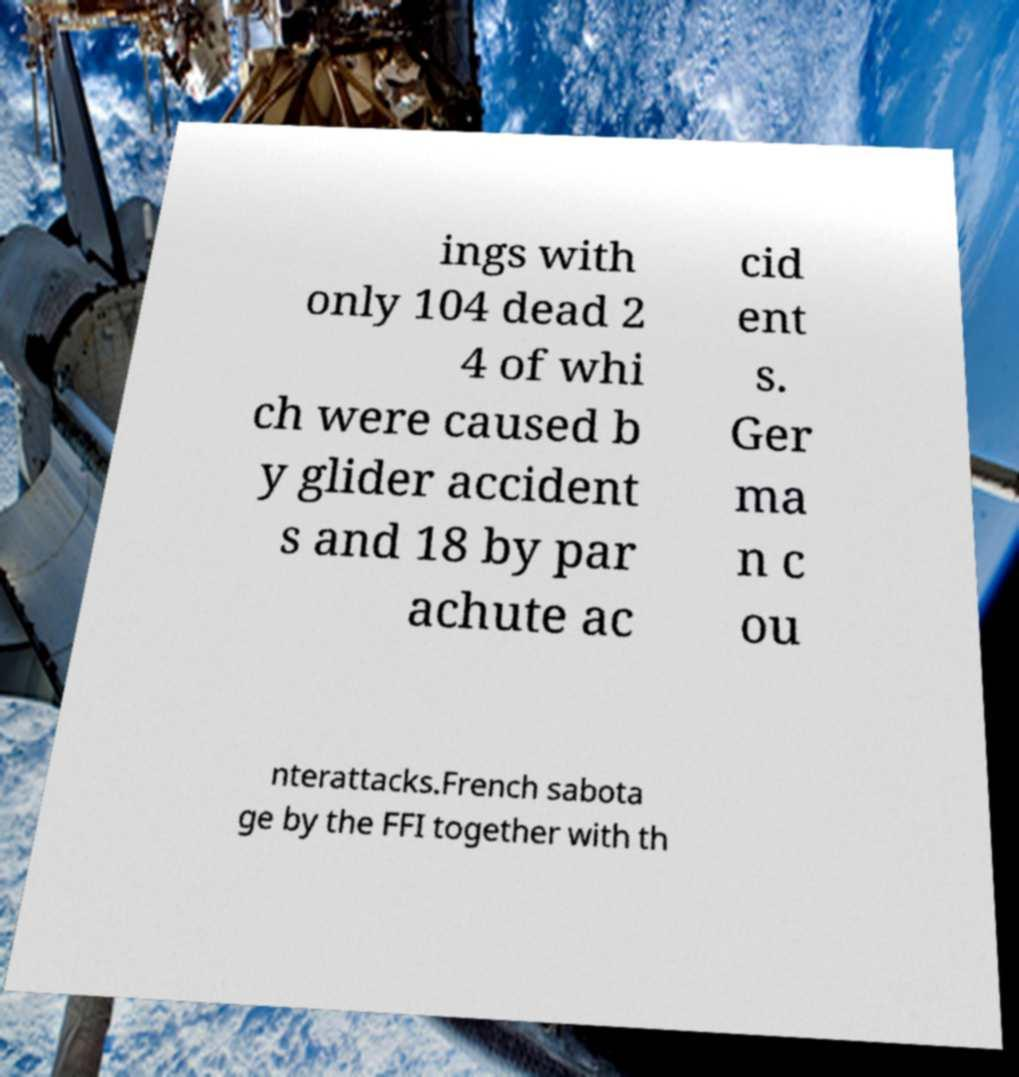Could you extract and type out the text from this image? ings with only 104 dead 2 4 of whi ch were caused b y glider accident s and 18 by par achute ac cid ent s. Ger ma n c ou nterattacks.French sabota ge by the FFI together with th 